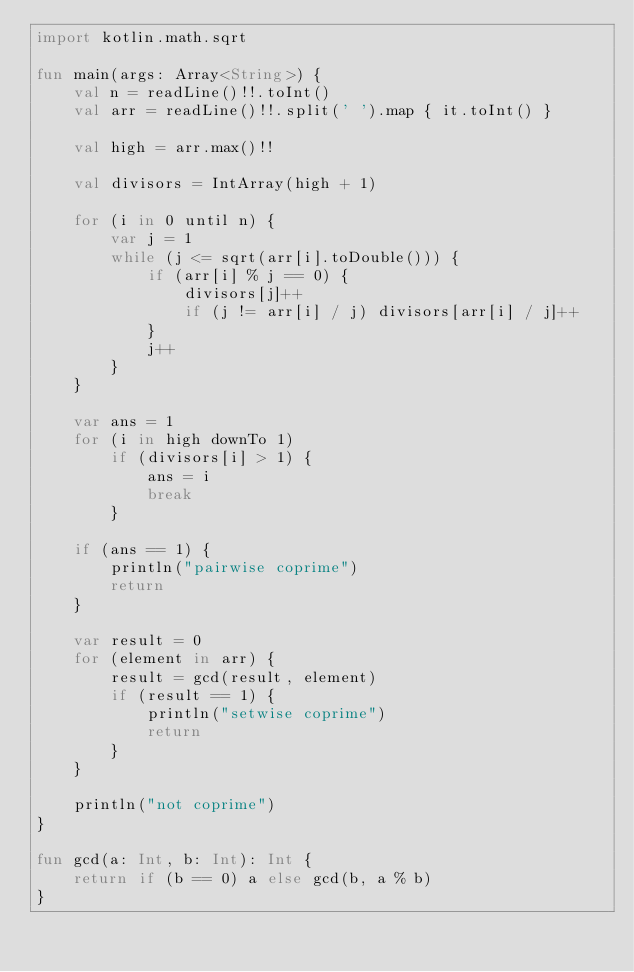<code> <loc_0><loc_0><loc_500><loc_500><_Kotlin_>import kotlin.math.sqrt

fun main(args: Array<String>) {
    val n = readLine()!!.toInt()
    val arr = readLine()!!.split(' ').map { it.toInt() }

    val high = arr.max()!!

    val divisors = IntArray(high + 1)

    for (i in 0 until n) {
        var j = 1
        while (j <= sqrt(arr[i].toDouble())) {
            if (arr[i] % j == 0) {
                divisors[j]++
                if (j != arr[i] / j) divisors[arr[i] / j]++
            }
            j++
        }
    }

    var ans = 1
    for (i in high downTo 1)
        if (divisors[i] > 1) {
            ans = i
            break
        }

    if (ans == 1) {
        println("pairwise coprime")
        return
    }

    var result = 0
    for (element in arr) {
        result = gcd(result, element)
        if (result == 1) {
            println("setwise coprime")
            return
        }
    }

    println("not coprime")
}

fun gcd(a: Int, b: Int): Int {
    return if (b == 0) a else gcd(b, a % b)
}</code> 